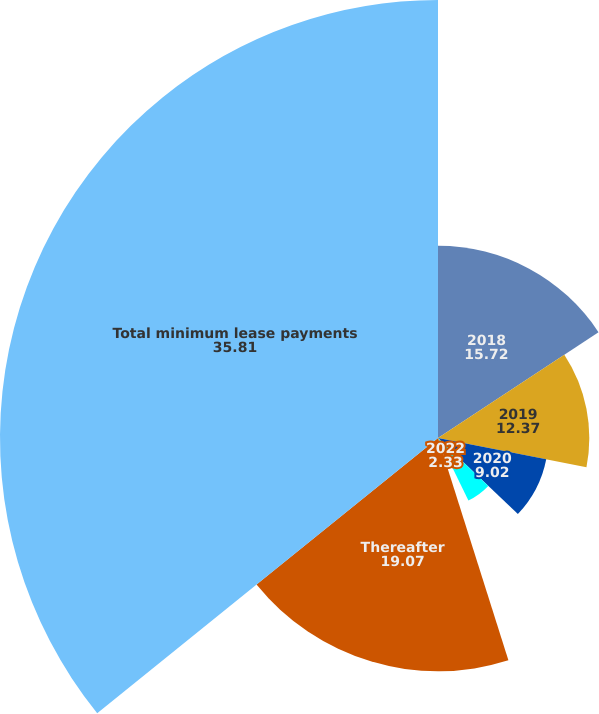<chart> <loc_0><loc_0><loc_500><loc_500><pie_chart><fcel>2018<fcel>2019<fcel>2020<fcel>2021<fcel>2022<fcel>Thereafter<fcel>Total minimum lease payments<nl><fcel>15.72%<fcel>12.37%<fcel>9.02%<fcel>5.68%<fcel>2.33%<fcel>19.07%<fcel>35.81%<nl></chart> 